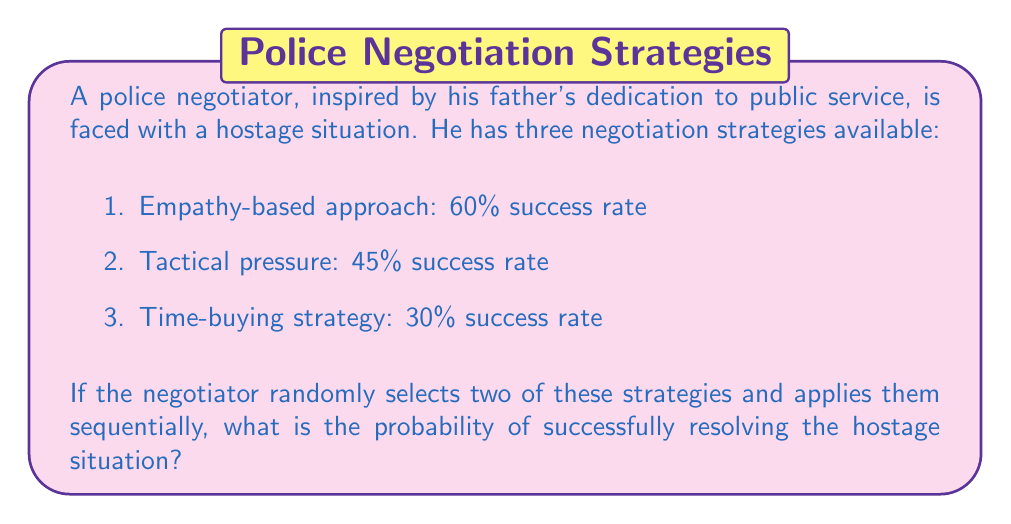Can you answer this question? Let's approach this step-by-step:

1) First, we need to calculate the probability of failure for each strategy:
   Empathy-based: $1 - 0.60 = 0.40$
   Tactical pressure: $1 - 0.45 = 0.55$
   Time-buying: $1 - 0.30 = 0.70$

2) There are three possible combinations of two strategies:
   a) Empathy-based and Tactical pressure
   b) Empathy-based and Time-buying
   c) Tactical pressure and Time-buying

3) For each combination, the probability of success is the probability that at least one of the strategies succeeds. This is equal to 1 minus the probability that both strategies fail.

4) Let's calculate the success probability for each combination:
   a) $P(\text{Empathy or Tactical}) = 1 - (0.40 \times 0.55) = 0.78$
   b) $P(\text{Empathy or Time-buying}) = 1 - (0.40 \times 0.70) = 0.72$
   c) $P(\text{Tactical or Time-buying}) = 1 - (0.55 \times 0.70) = 0.615$

5) Since the negotiator randomly selects two strategies, each combination has an equal probability of $\frac{1}{3}$ of being chosen.

6) The overall probability of success is the weighted average of these probabilities:

   $$P(\text{Success}) = \frac{1}{3}(0.78 + 0.72 + 0.615) = \frac{0.78 + 0.72 + 0.615}{3} = \frac{2.115}{3} = 0.705$$

Therefore, the probability of successfully resolving the hostage situation is 0.705 or 70.5%.
Answer: 0.705 or 70.5% 